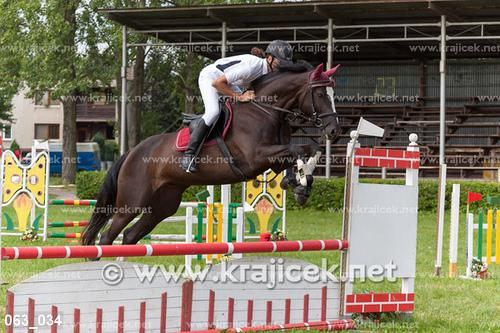Question: where was the photo taken?
Choices:
A. A circus.
B. At a horse jumping event.
C. A museum.
D. An amusement park.
Answer with the letter. Answer: B Question: how is the horse?
Choices:
A. In motion.
B. Sleeping.
C. Eating.
D. Healthy.
Answer with the letter. Answer: A Question: what color is the horse?
Choices:
A. Black.
B. White.
C. Tan.
D. Brown.
Answer with the letter. Answer: D Question: what is the girl wearing on her head?
Choices:
A. A helmet.
B. A cap.
C. A beret.
D. A ribbon.
Answer with the letter. Answer: B Question: who is in the photo?
Choices:
A. A boy.
B. A baby.
C. A girl.
D. A woman.
Answer with the letter. Answer: C 